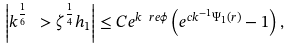<formula> <loc_0><loc_0><loc_500><loc_500>\left | k ^ { \frac { 1 } { 6 } } \ > \zeta ^ { \frac { 1 } { 4 } } h _ { 1 } \right | \leq C e ^ { k \ r e \phi } \left ( e ^ { c k ^ { - 1 } \Psi _ { 1 } ( r ) } - 1 \right ) ,</formula> 